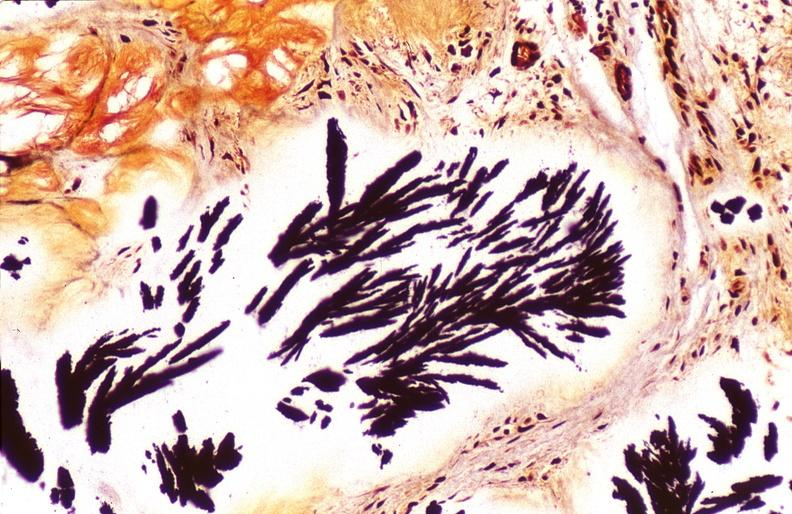what does this image show?
Answer the question using a single word or phrase. Gout 